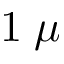Convert formula to latex. <formula><loc_0><loc_0><loc_500><loc_500>1 \, \mu</formula> 